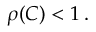<formula> <loc_0><loc_0><loc_500><loc_500>\rho ( C ) < 1 \, .</formula> 